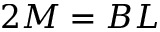Convert formula to latex. <formula><loc_0><loc_0><loc_500><loc_500>2 M = B L</formula> 